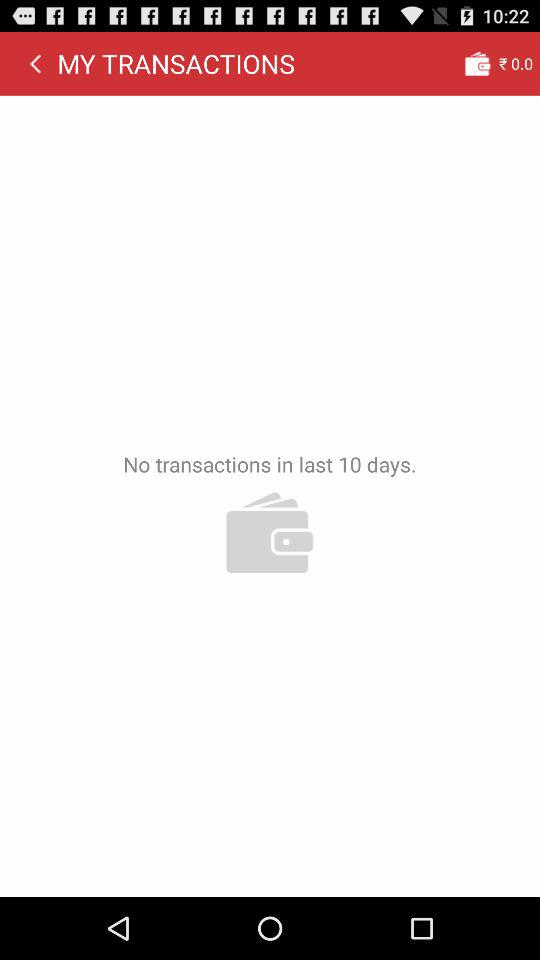For how many days has the transaction not been done? The transaction has not been done for the last 10 days. 